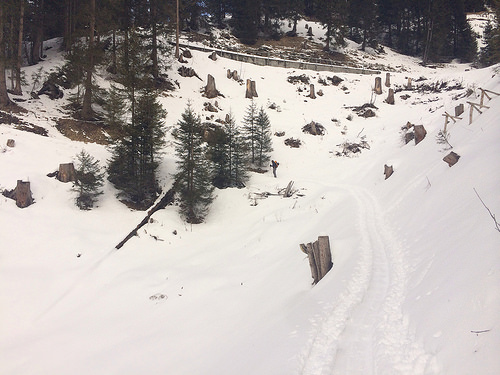<image>
Is there a snow on the tree? No. The snow is not positioned on the tree. They may be near each other, but the snow is not supported by or resting on top of the tree. 